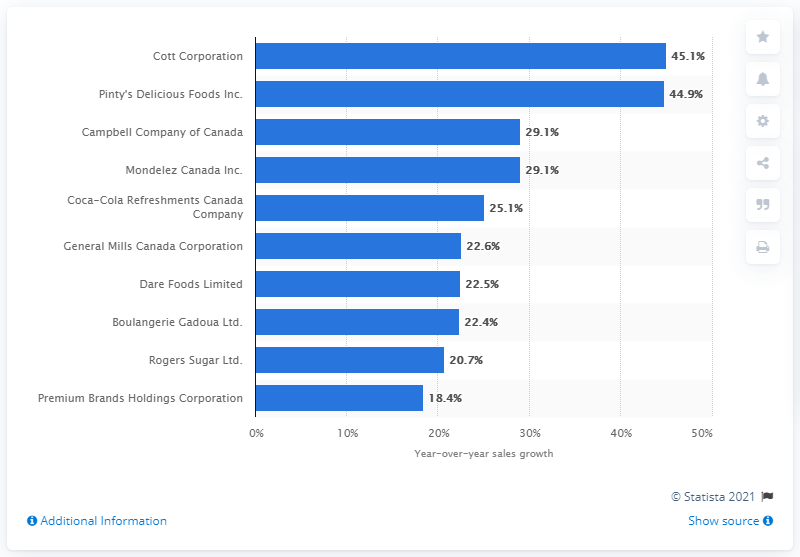Can you tell me more about the source of this information? Certainly, the source indicated on the chart is Statista 2021, which is a reputable provider of market and consumer data. The watermark implies authenticity and accuracy of the sales growth figures presented. How might this data be useful for a market analyst? A market analyst could use this data to identify industry trends, assess company performance compared to competitors, and make informed decisions on investments, strategy, and market opportunities. 